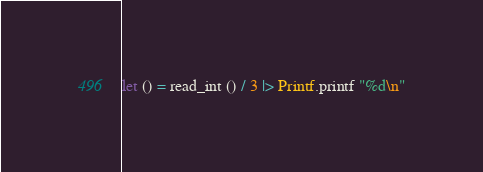Convert code to text. <code><loc_0><loc_0><loc_500><loc_500><_OCaml_>let () = read_int () / 3 |> Printf.printf "%d\n"</code> 